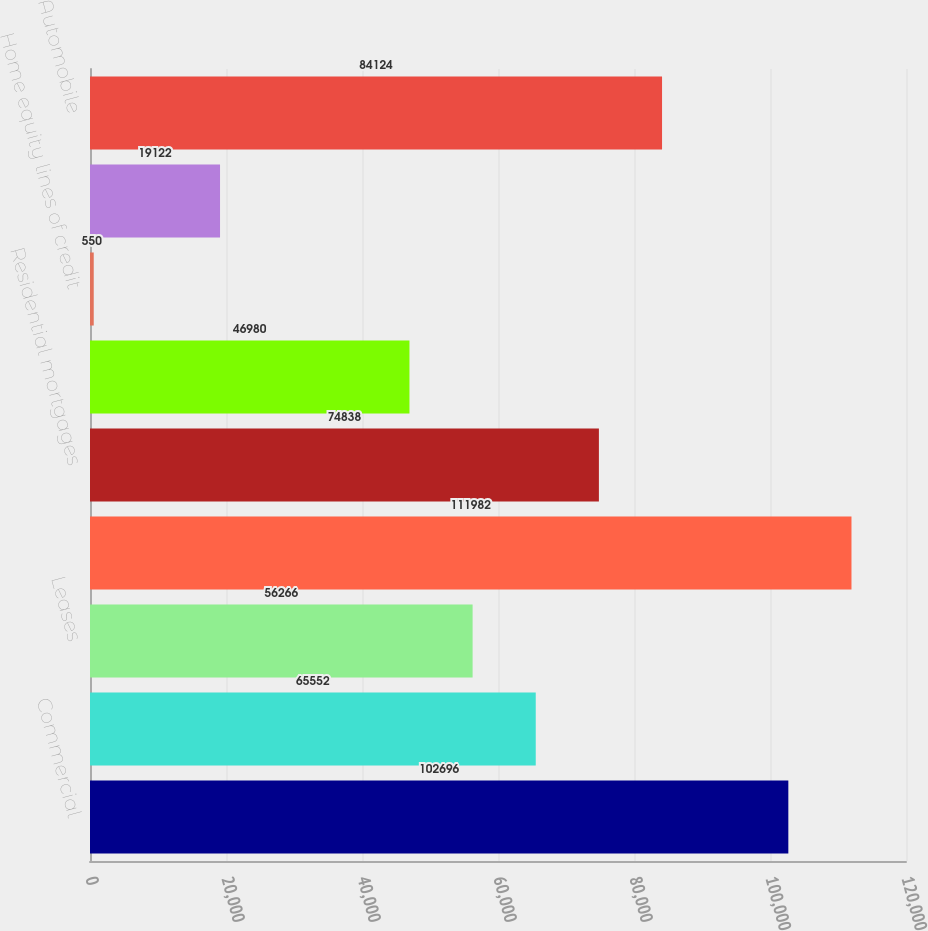Convert chart. <chart><loc_0><loc_0><loc_500><loc_500><bar_chart><fcel>Commercial<fcel>Commercial real estate<fcel>Leases<fcel>Total commercial loans and<fcel>Residential mortgages<fcel>Home equity loans<fcel>Home equity lines of credit<fcel>Home equity loans serviced by<fcel>Automobile<nl><fcel>102696<fcel>65552<fcel>56266<fcel>111982<fcel>74838<fcel>46980<fcel>550<fcel>19122<fcel>84124<nl></chart> 